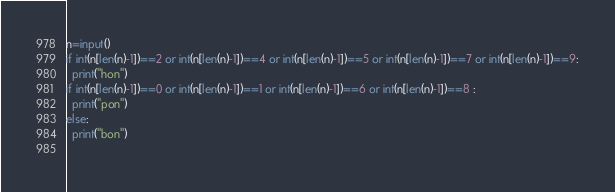Convert code to text. <code><loc_0><loc_0><loc_500><loc_500><_Python_>n=input()
if int(n[len(n)-1])==2 or int(n[len(n)-1])==4 or int(n[len(n)-1])==5 or int(n[len(n)-1])==7 or int(n[len(n)-1])==9:
  print("hon")
if int(n[len(n)-1])==0 or int(n[len(n)-1])==1 or int(n[len(n)-1])==6 or int(n[len(n)-1])==8 :
  print("pon")
else:
  print("bon")
  
</code> 